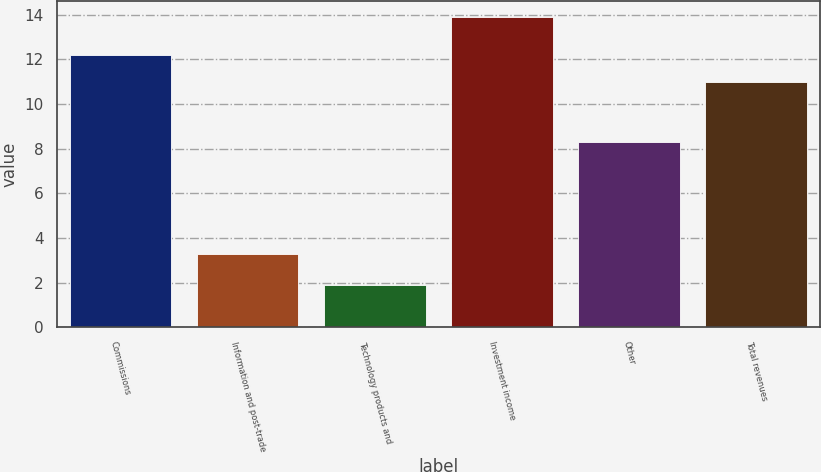<chart> <loc_0><loc_0><loc_500><loc_500><bar_chart><fcel>Commissions<fcel>Information and post-trade<fcel>Technology products and<fcel>Investment income<fcel>Other<fcel>Total revenues<nl><fcel>12.2<fcel>3.3<fcel>1.9<fcel>13.9<fcel>8.3<fcel>11<nl></chart> 